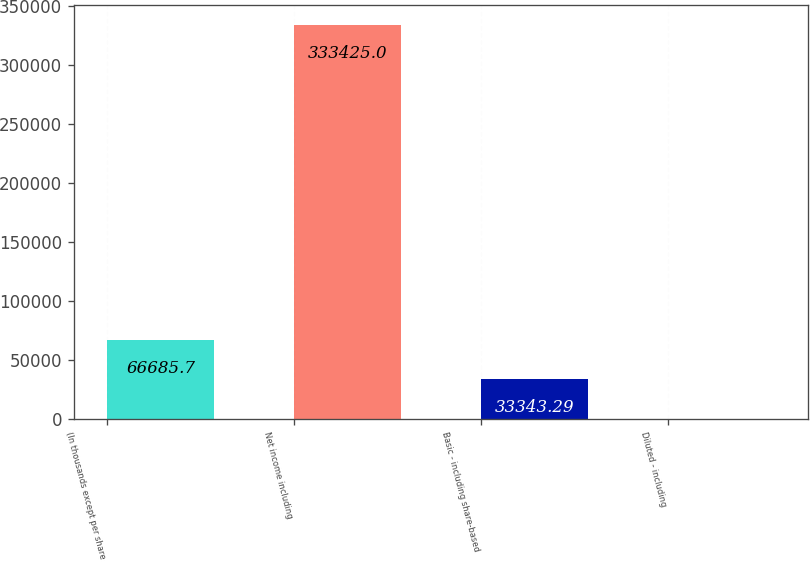Convert chart. <chart><loc_0><loc_0><loc_500><loc_500><bar_chart><fcel>(In thousands except per share<fcel>Net income including<fcel>Basic - including share-based<fcel>Diluted - including<nl><fcel>66685.7<fcel>333425<fcel>33343.3<fcel>0.88<nl></chart> 